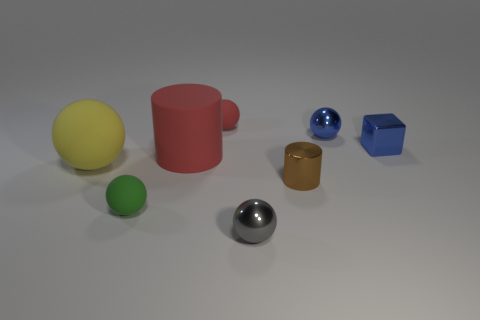What number of other big cylinders are the same color as the big cylinder?
Your response must be concise. 0. Is the tiny gray metal thing the same shape as the brown shiny thing?
Your answer should be very brief. No. What size is the red thing that is in front of the tiny blue thing that is on the left side of the blue cube?
Offer a very short reply. Large. Are there any green spheres of the same size as the gray thing?
Provide a succinct answer. Yes. There is a metallic thing right of the tiny blue metallic ball; is its size the same as the cylinder that is to the left of the gray metal object?
Provide a short and direct response. No. The red object to the left of the small matte ball right of the rubber cylinder is what shape?
Ensure brevity in your answer.  Cylinder. There is a yellow rubber ball; how many large objects are behind it?
Ensure brevity in your answer.  1. The cylinder that is made of the same material as the small red ball is what color?
Give a very brief answer. Red. There is a blue sphere; is it the same size as the matte ball behind the yellow sphere?
Keep it short and to the point. Yes. There is a red matte thing in front of the object that is right of the blue metallic object that is to the left of the small blue shiny block; what is its size?
Offer a very short reply. Large. 